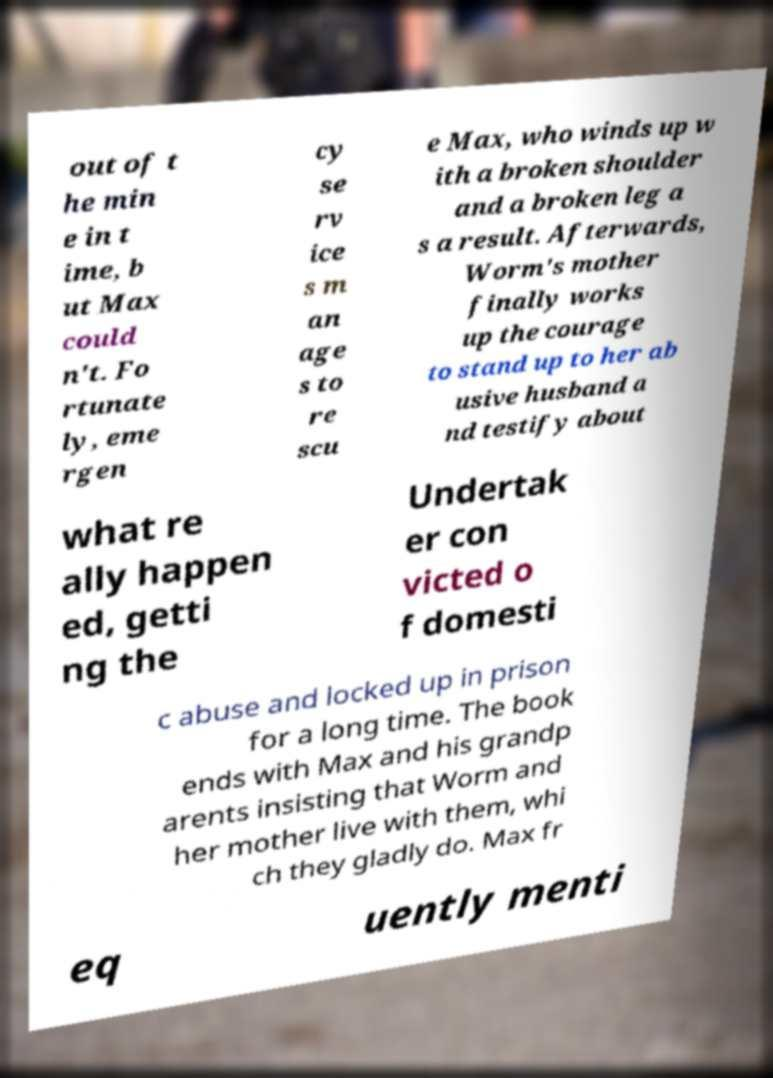Can you read and provide the text displayed in the image?This photo seems to have some interesting text. Can you extract and type it out for me? out of t he min e in t ime, b ut Max could n't. Fo rtunate ly, eme rgen cy se rv ice s m an age s to re scu e Max, who winds up w ith a broken shoulder and a broken leg a s a result. Afterwards, Worm's mother finally works up the courage to stand up to her ab usive husband a nd testify about what re ally happen ed, getti ng the Undertak er con victed o f domesti c abuse and locked up in prison for a long time. The book ends with Max and his grandp arents insisting that Worm and her mother live with them, whi ch they gladly do. Max fr eq uently menti 